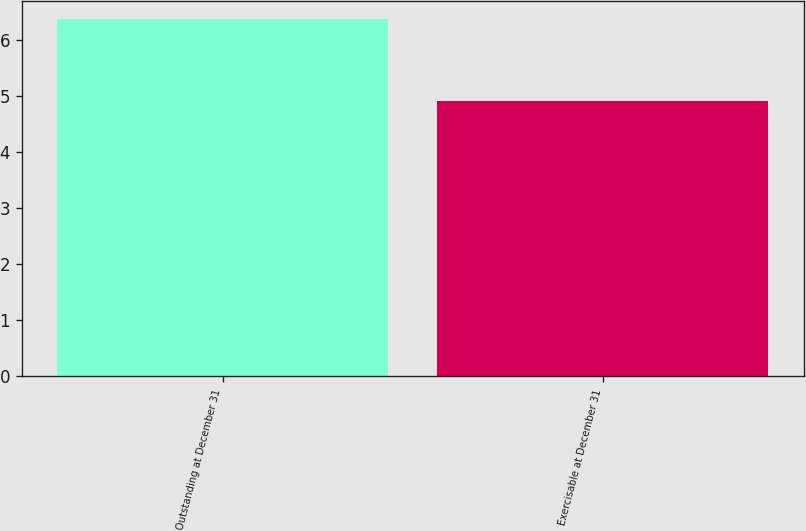<chart> <loc_0><loc_0><loc_500><loc_500><bar_chart><fcel>Outstanding at December 31<fcel>Exercisable at December 31<nl><fcel>6.37<fcel>4.91<nl></chart> 